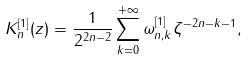<formula> <loc_0><loc_0><loc_500><loc_500>K ^ { [ 1 ] } _ { n } ( z ) = \frac { 1 } { 2 ^ { 2 n - 2 } } \sum _ { k = 0 } ^ { + \infty } \omega ^ { [ 1 ] } _ { n , k } \zeta ^ { - 2 n - k - 1 } ,</formula> 